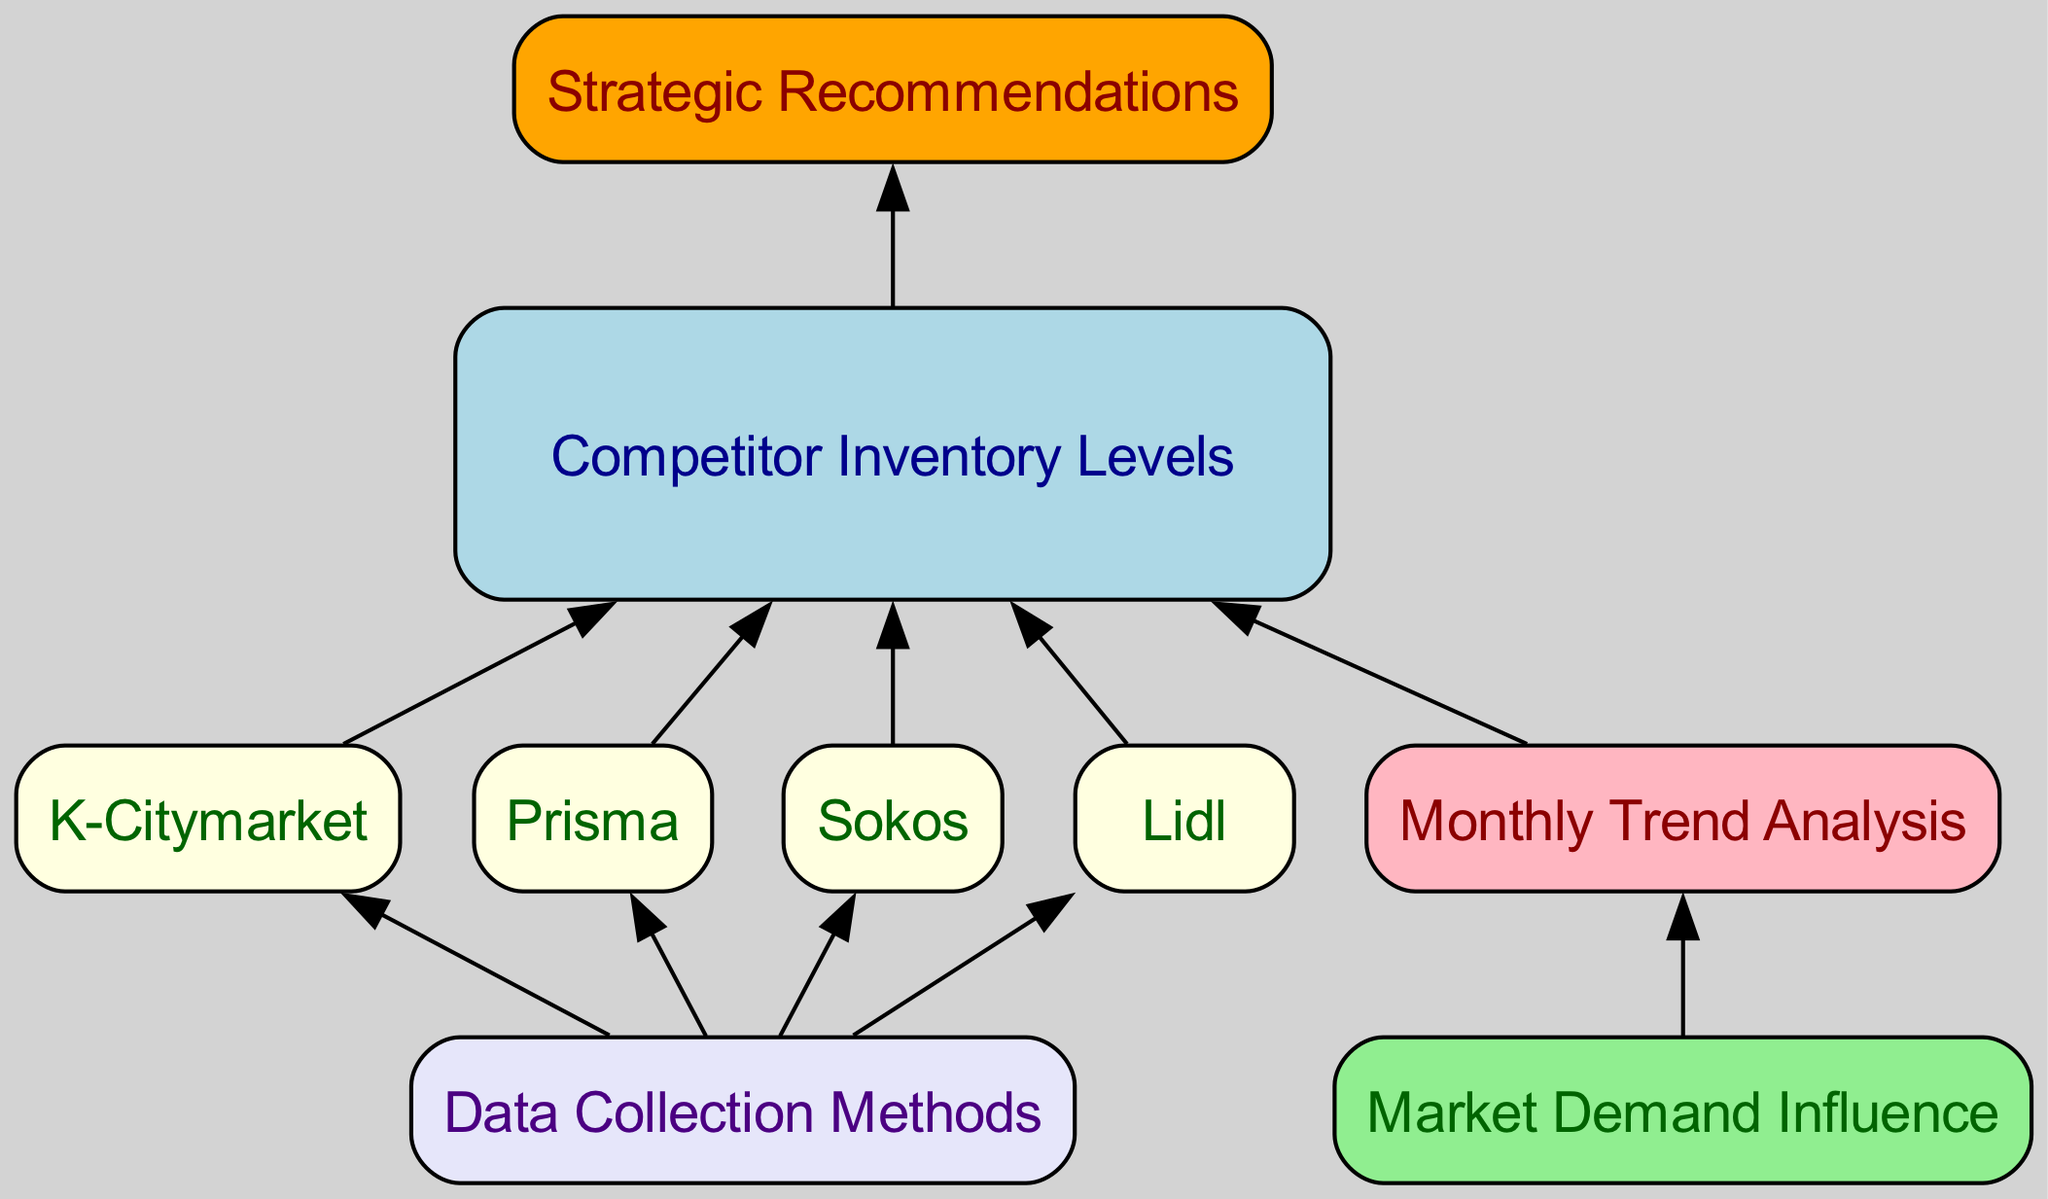What are the major competitors analyzed in this diagram? The diagram lists the major competitors under the "Competitor Inventory Levels" node, specifically K-Citymarket, Prisma, Sokos, and Lidl, as part of the inventory analysis.
Answer: K-Citymarket, Prisma, Sokos, Lidl How many edges connect the main competitor nodes to the Competitor Inventory level? Each of the competitor nodes (K-Citymarket, Prisma, Sokos, and Lidl) connects to the Competitor Inventory node, resulting in four edges linking individual competitors to the main inventory level.
Answer: Four What is the purpose of the "Monthly Trend Analysis" node? The "Monthly Trend Analysis" node serves to visualize and analyze trends in inventory levels over the past months, providing insights into how inventory has changed with respect to time.
Answer: Analyze trends Which node receives edges from all competitor inventory nodes? The "Competitor Inventory" node is the one that all individual competitor nodes connect to, indicating it collects data from each of the competitors analyzed.
Answer: Competitor Inventory What type of evaluation is performed by the "Market Demand Influence" node? This node evaluates the impact of market demand on inventory levels, suggesting how external factors might affect competitor stock and availability.
Answer: Evaluation of demand Which nodes are connected to "Data Collection Methods"? The "Data Collection Methods" node connects to all the competitor nodes (K-Citymarket, Prisma, Sokos, and Lidl), indicating that it outlines methods for gathering data from these specific competitors.
Answer: K-Citymarket, Prisma, Sokos, Lidl What follows the "Inventory Trends" node in the flow chart? The flow chart indicates that after the "Inventory Trends" node, the next in line is the "Market Demand Influence," showing a dependency on understanding trends before looking at market impacts.
Answer: Market Demand Influence What strategic output does the "Recommendations" node provide? This node offers strategic recommendations based on analyzed inventory trends and competitor evaluations to inform future actions and strategies.
Answer: Strategic Recommendations 